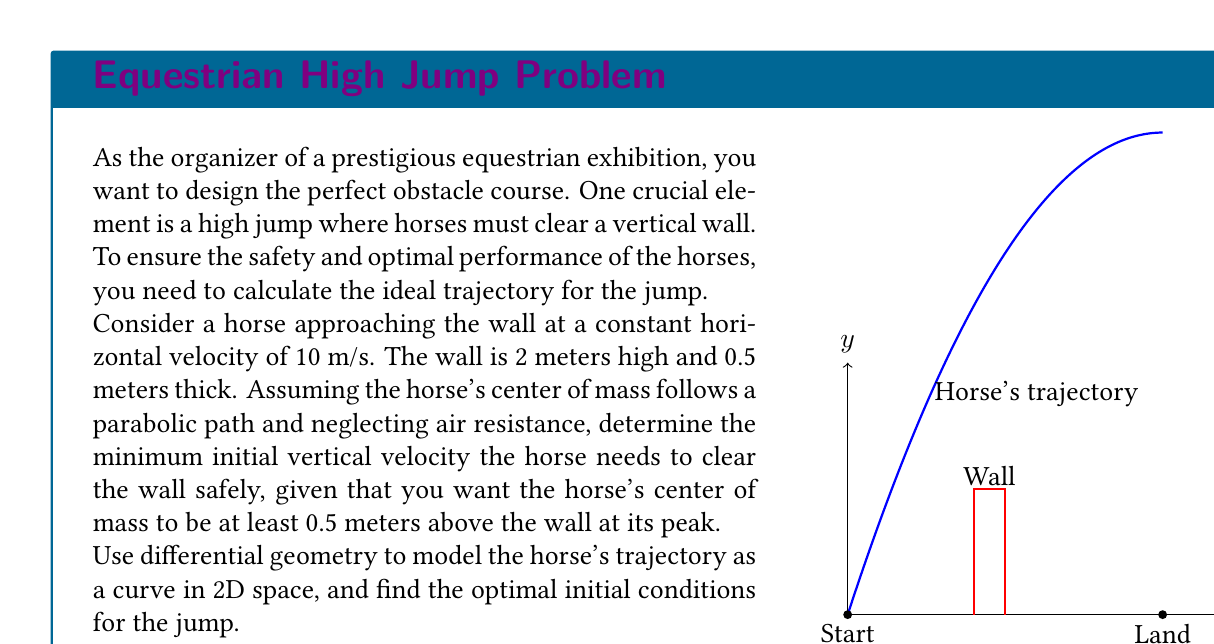Solve this math problem. Let's approach this problem step by step using differential geometry:

1) The horse's trajectory can be modeled as a curve $\gamma(t)$ in 2D space:

   $$\gamma(t) = (x(t), y(t))$$

   where $x(t)$ and $y(t)$ represent the horizontal and vertical positions at time $t$.

2) Given constant horizontal velocity, we have:

   $$x(t) = vt$$

   where $v = 10$ m/s is the horizontal velocity.

3) The vertical motion follows the equation:

   $$y(t) = y_0 + v_0t - \frac{1}{2}gt^2$$

   where $y_0$ is the initial height (0 m), $v_0$ is the initial vertical velocity (to be determined), and $g$ is the acceleration due to gravity (9.8 m/s²).

4) The time $t_w$ when the horse reaches the wall is:

   $$t_w = \frac{2}{v} = 0.2\text{ s}$$

5) At this time, the height should be at least 2.5 m (wall height + 0.5 m clearance):

   $$2.5 \leq v_0(0.2) - \frac{1}{2}(9.8)(0.2)^2$$

6) Solving this inequality:

   $$v_0 \geq \frac{2.5 + \frac{1}{2}(9.8)(0.2)^2}{0.2} = 13.48\text{ m/s}$$

7) To find the minimum $v_0$, we use the equality:

   $$v_0 = 13.48\text{ m/s}$$

8) The trajectory curve can now be expressed as:

   $$\gamma(t) = (10t, 13.48t - 4.9t^2)$$

9) To verify the peak height occurs above the wall, we can find the maximum of $y(t)$:

   $$\frac{dy}{dt} = 13.48 - 9.8t = 0$$
   $$t_{peak} = 1.376\text{ s}$$

   This occurs after the horse has passed the wall, confirming our calculation.
Answer: $v_0 = 13.48\text{ m/s}$ 